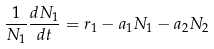Convert formula to latex. <formula><loc_0><loc_0><loc_500><loc_500>\frac { 1 } { N _ { 1 } } \frac { d N _ { 1 } } { d t } = r _ { 1 } - a _ { 1 } N _ { 1 } - a _ { 2 } N _ { 2 }</formula> 